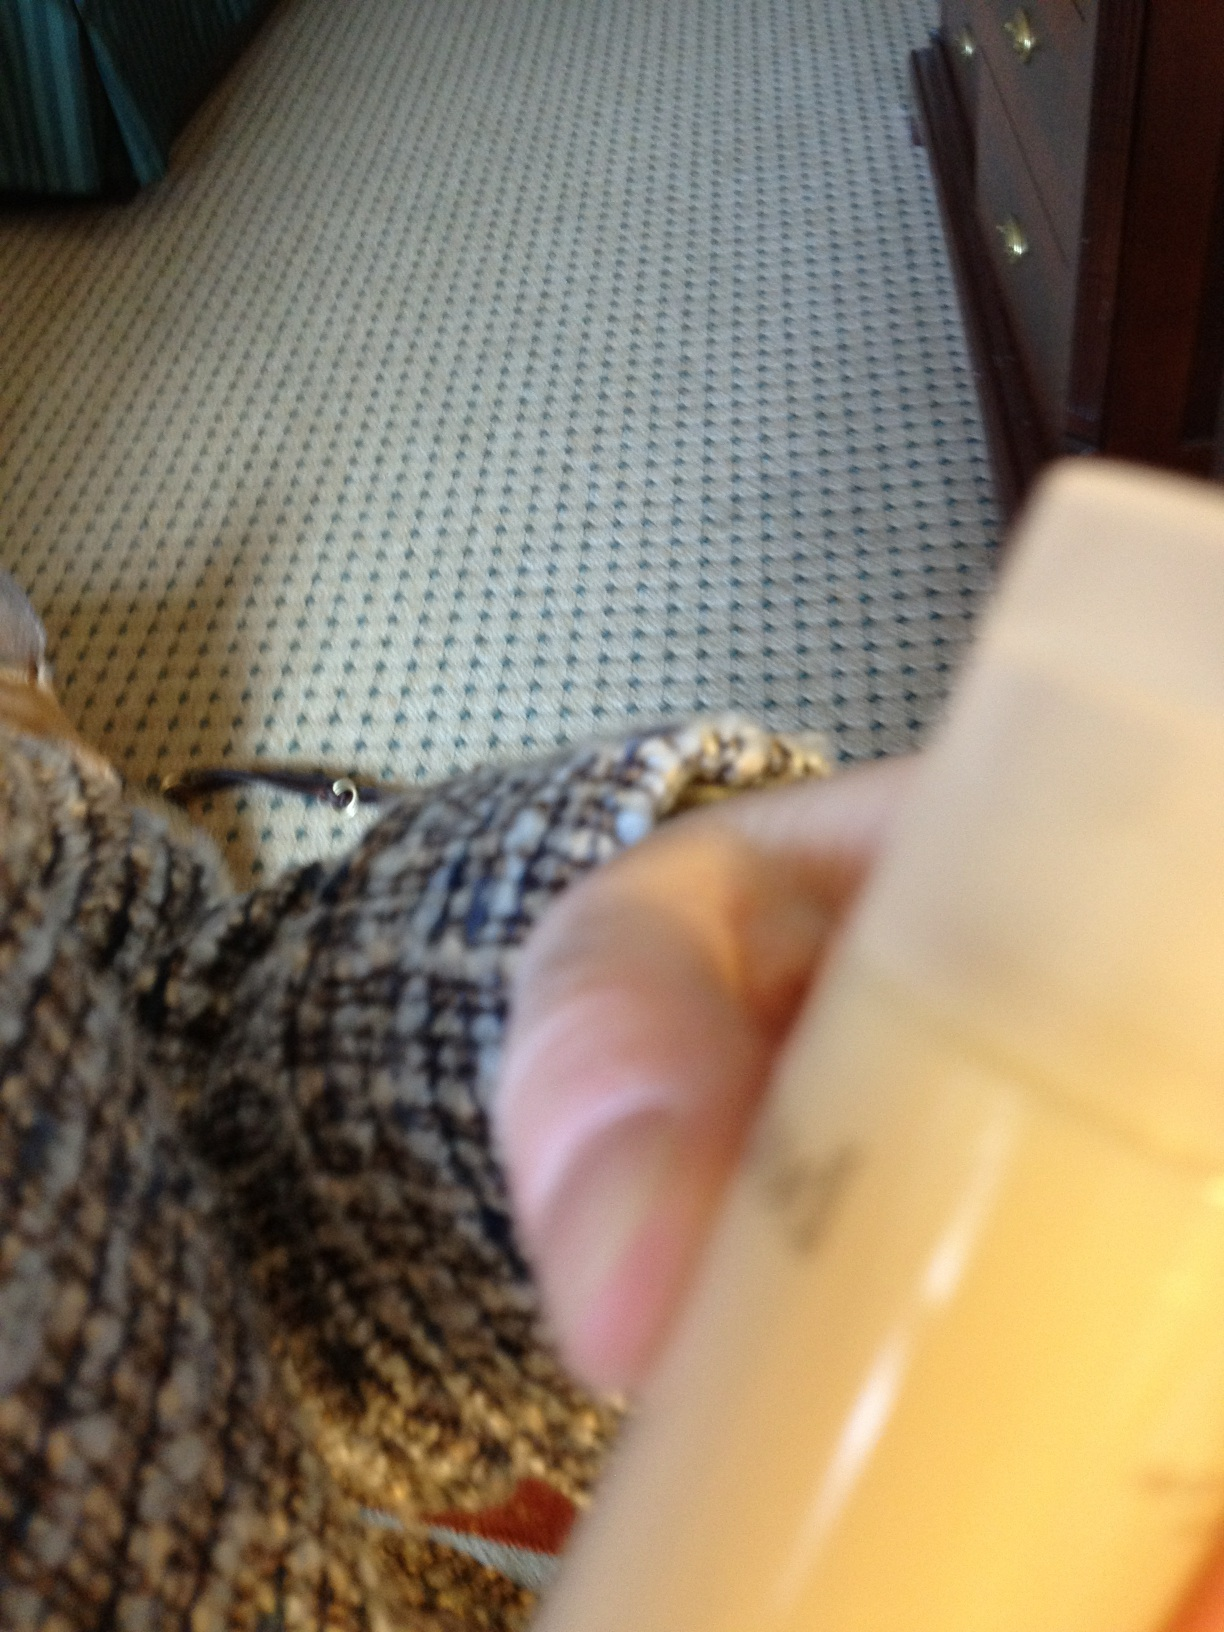Is there any discernable text or logo that can help identify the brand or further details about the product? Unfortunately, the text or logos aren't visible in this image due to the focus and angle. Identifying the brand or product specifics such as ingredients or usage instructions isn't possible from this view. 